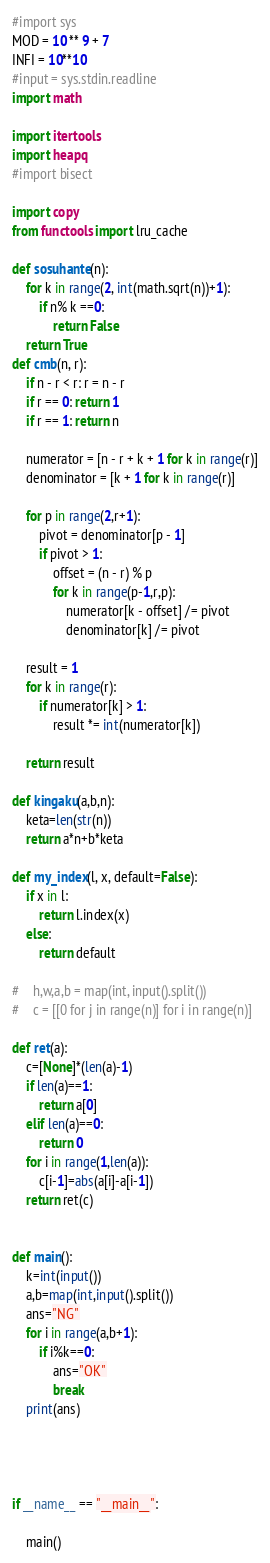Convert code to text. <code><loc_0><loc_0><loc_500><loc_500><_Python_>#import sys
MOD = 10 ** 9 + 7
INFI = 10**10
#input = sys.stdin.readline
import math

import itertools
import heapq
#import bisect

import copy
from functools import lru_cache

def sosuhante(n):
    for k in range(2, int(math.sqrt(n))+1):
        if n% k ==0:
            return False
    return True
def cmb(n, r):
    if n - r < r: r = n - r
    if r == 0: return 1
    if r == 1: return n

    numerator = [n - r + k + 1 for k in range(r)]
    denominator = [k + 1 for k in range(r)]

    for p in range(2,r+1):
        pivot = denominator[p - 1]
        if pivot > 1:
            offset = (n - r) % p
            for k in range(p-1,r,p):
                numerator[k - offset] /= pivot
                denominator[k] /= pivot

    result = 1
    for k in range(r):
        if numerator[k] > 1:
            result *= int(numerator[k])

    return result

def kingaku(a,b,n):
    keta=len(str(n))
    return a*n+b*keta

def my_index(l, x, default=False):
    if x in l:
        return l.index(x)
    else:
        return default

#    h,w,a,b = map(int, input().split())
#    c = [[0 for j in range(n)] for i in range(n)]

def ret(a):
    c=[None]*(len(a)-1)
    if len(a)==1:
        return a[0]
    elif len(a)==0:
        return 0
    for i in range(1,len(a)):
        c[i-1]=abs(a[i]-a[i-1])
    return ret(c)


def main():
    k=int(input())
    a,b=map(int,input().split())
    ans="NG"
    for i in range(a,b+1):
        if i%k==0:
            ans="OK"
            break
    print(ans)




if __name__ == "__main__":

    main()</code> 